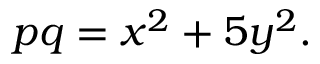<formula> <loc_0><loc_0><loc_500><loc_500>p q = x ^ { 2 } + 5 y ^ { 2 } .</formula> 